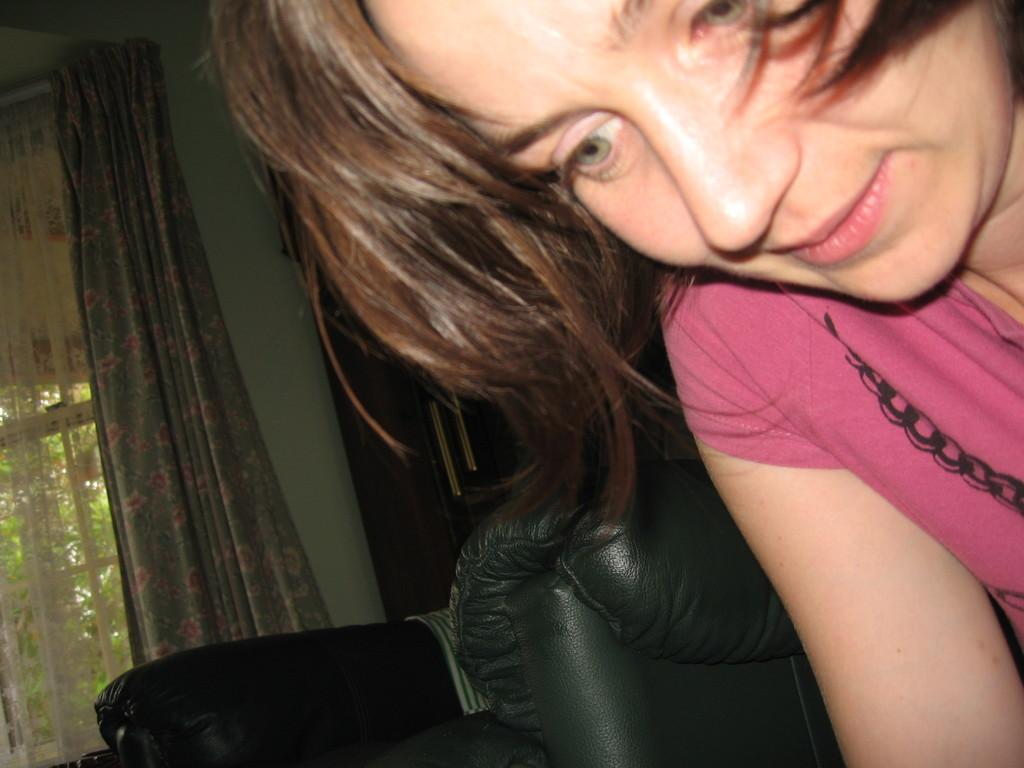Who is present in the image? There is a woman in the image. What can be seen in the background of the image? There is a wall, a window, a curtain, trees, and some unspecified objects in the background of the image. How many icicles are hanging from the woman's hair in the image? There are no icicles present in the image. What type of bean is growing on the wall in the background of the image? There are no beans present in the image. 